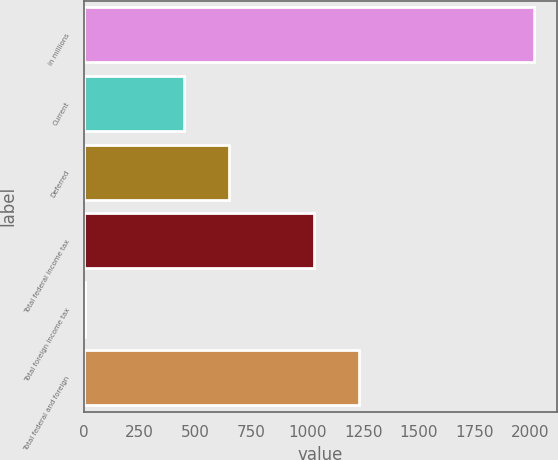Convert chart to OTSL. <chart><loc_0><loc_0><loc_500><loc_500><bar_chart><fcel>in millions<fcel>Current<fcel>Deferred<fcel>Total federal income tax<fcel>Total foreign income tax<fcel>Total federal and foreign<nl><fcel>2017<fcel>449<fcel>650.3<fcel>1030<fcel>4<fcel>1231.3<nl></chart> 